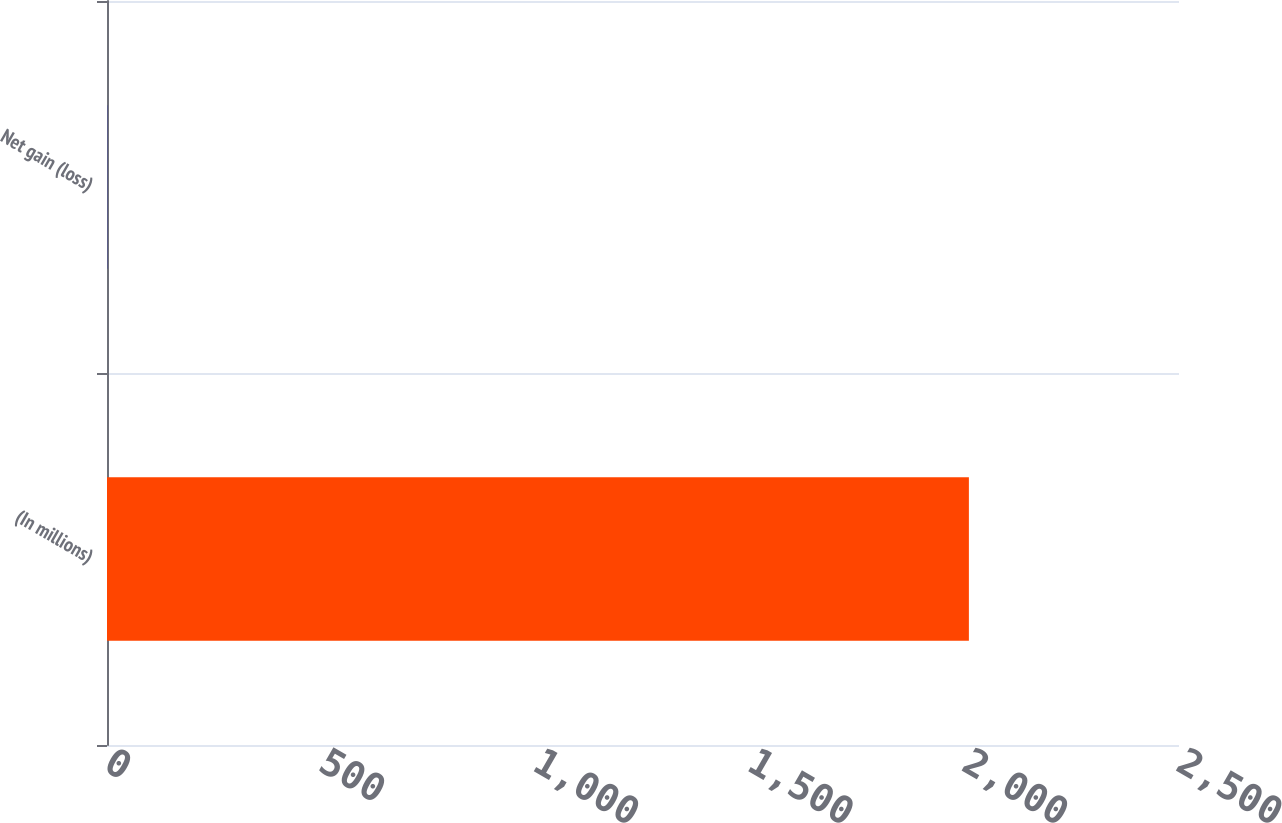<chart> <loc_0><loc_0><loc_500><loc_500><bar_chart><fcel>(In millions)<fcel>Net gain (loss)<nl><fcel>2010<fcel>0.4<nl></chart> 